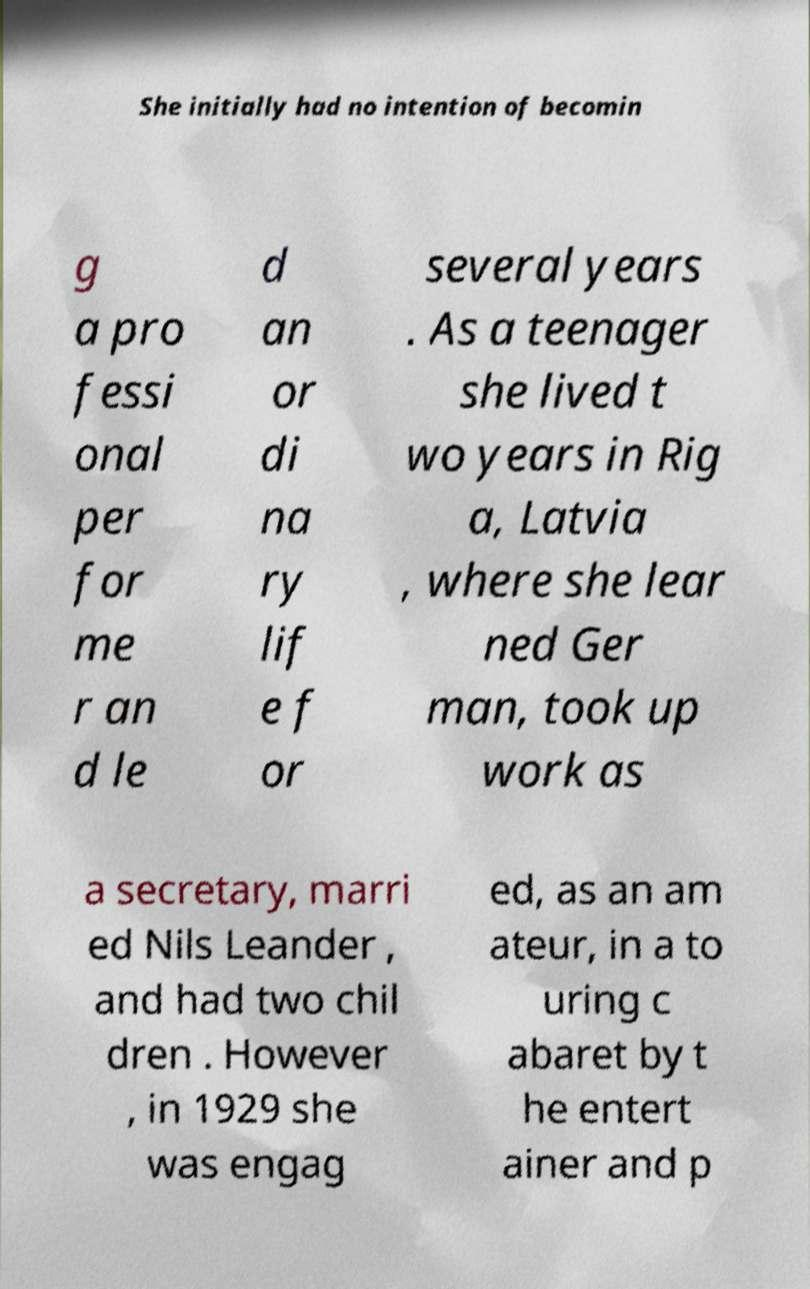What messages or text are displayed in this image? I need them in a readable, typed format. She initially had no intention of becomin g a pro fessi onal per for me r an d le d an or di na ry lif e f or several years . As a teenager she lived t wo years in Rig a, Latvia , where she lear ned Ger man, took up work as a secretary, marri ed Nils Leander , and had two chil dren . However , in 1929 she was engag ed, as an am ateur, in a to uring c abaret by t he entert ainer and p 